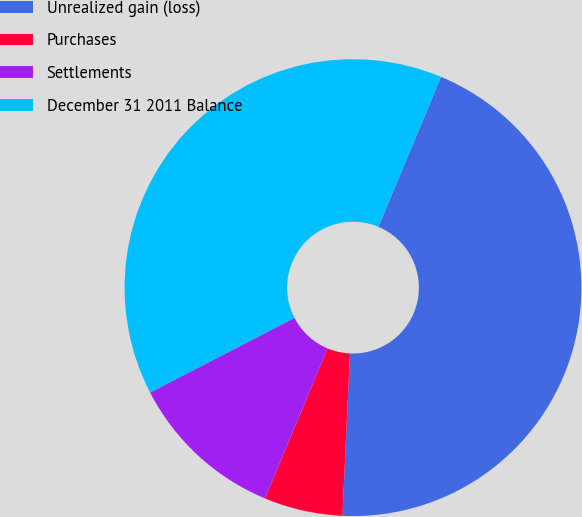Convert chart. <chart><loc_0><loc_0><loc_500><loc_500><pie_chart><fcel>Unrealized gain (loss)<fcel>Purchases<fcel>Settlements<fcel>December 31 2011 Balance<nl><fcel>44.44%<fcel>5.56%<fcel>11.11%<fcel>38.89%<nl></chart> 